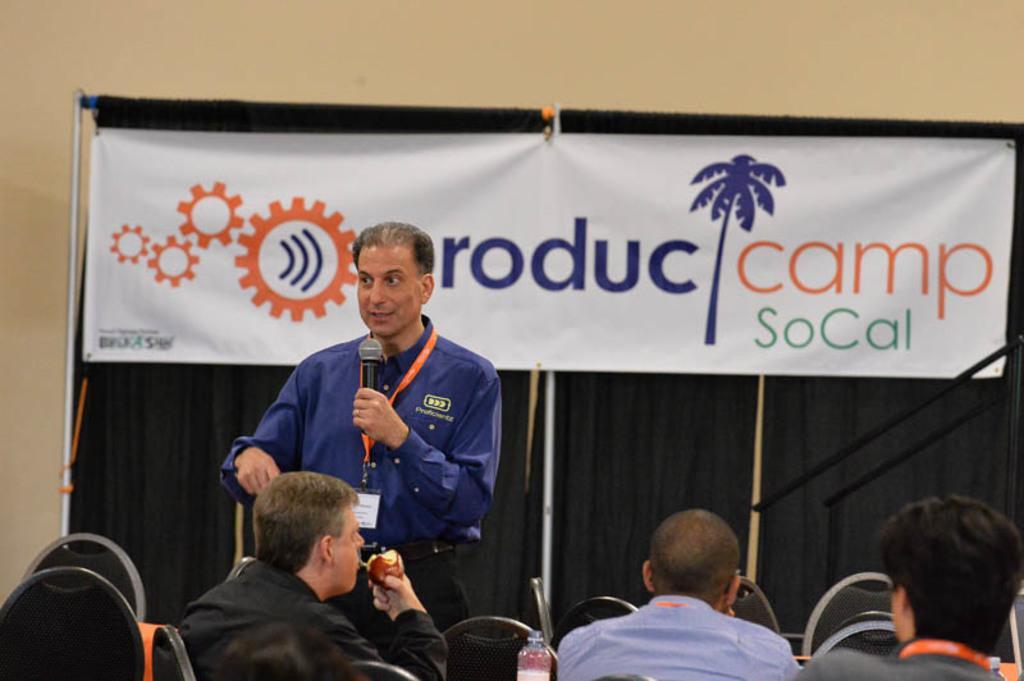Can you describe this image briefly? As we can see in the image there is a wall, banner, few people sitting on chairs and the man who is standing here is holding mic. 